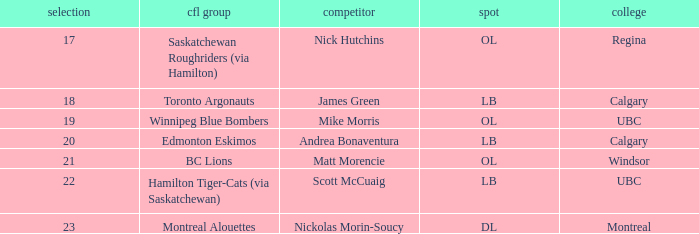Which player is on the BC Lions?  Matt Morencie. 